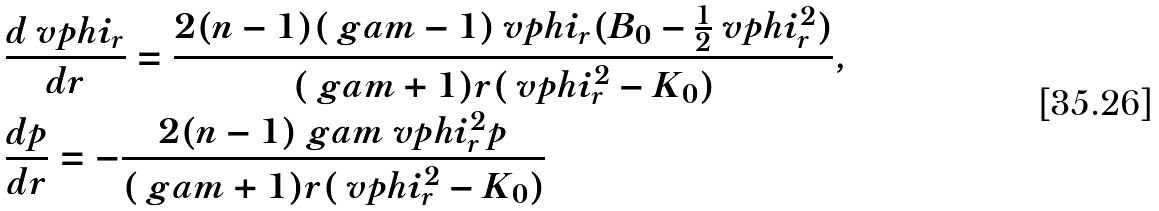Convert formula to latex. <formula><loc_0><loc_0><loc_500><loc_500>& \frac { d \ v p h i _ { r } } { d r } = \frac { 2 ( n - 1 ) ( \ g a m - 1 ) \ v p h i _ { r } ( B _ { 0 } - \frac { 1 } { 2 } \ v p h i _ { r } ^ { 2 } ) } { ( \ g a m + 1 ) r ( \ v p h i _ { r } ^ { 2 } - K _ { 0 } ) } , \\ & \frac { d p } { d r } = - \frac { 2 ( n - 1 ) \ g a m \ v p h i _ { r } ^ { 2 } p } { ( \ g a m + 1 ) r ( \ v p h i _ { r } ^ { 2 } - K _ { 0 } ) }</formula> 